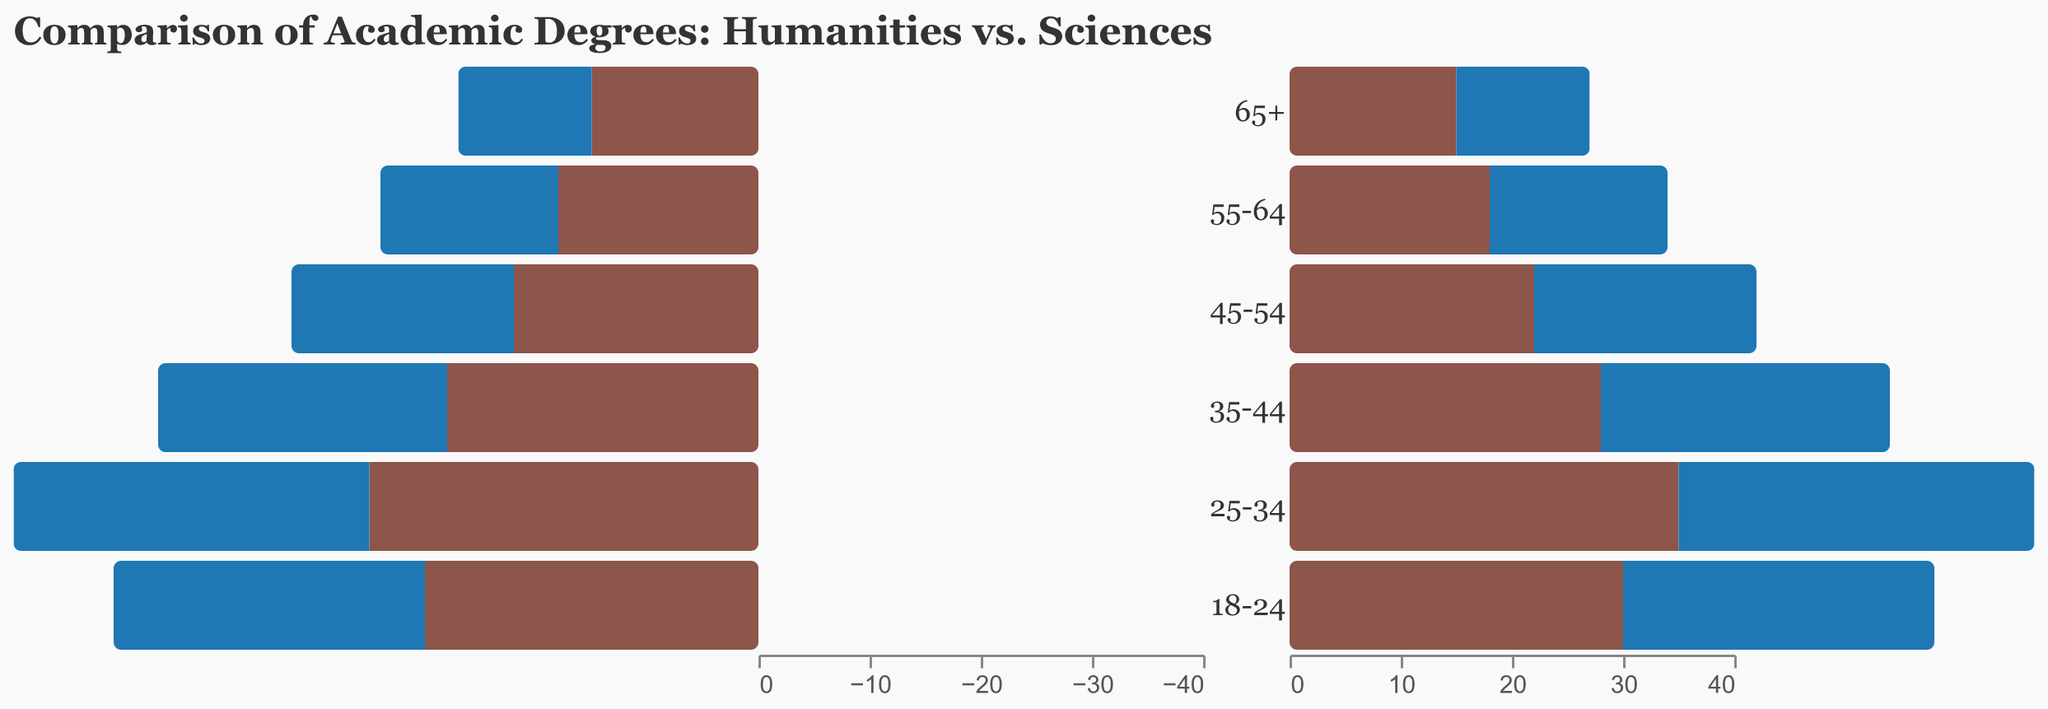What's the title of the figure? The title of the figure appears at the top and provides an indication of what the figure is about. In this case, it is "Comparison of Academic Degrees: Humanities vs. Sciences".
Answer: Comparison of Academic Degrees: Humanities vs. Sciences What color represents the Humanities degrees in the figure? Based on the legend and the color of the bars, Humanities degrees are represented by a specific color. Here, it's indicated by a shade of brown.
Answer: Brown Which age group shows the highest number of Science degrees? To find the age group with the highest number of Science degrees, observe the length of the blue bars representing Science degrees. The longest blue bar is for the age group "25-34".
Answer: 25-34 What is the difference in the number of Humanities degrees between the age groups 25-34 and 18-24? Find the values for these age groups in the Humanities column: -35 for 25-34 and -30 for 18-24. The difference is calculated as -35 - (-30) = -5.
Answer: -5 How do the trends in Humanities degrees compare to Science degrees across generations? Observe the trends in the lengths of both brown and blue bars from one age group to the next. Humanities degrees consistently decrease, while Science degrees consistently increase. This indicates a drop in Humanities degrees and a rise in Science degrees over time.
Answer: Humanities decrease, Sciences increase Which field has a larger discrepancy between the youngest (18-24) and oldest (65+) age groups? Calculate the difference for each field. For Humanities: -30 - (-15) = -15. For Sciences: 28 - 12 = 16. The larger discrepancy is in Science degrees.
Answer: Sciences In the age group 45-54, are there more academic degrees earned in Humanities or Sciences? Compare the length of the bars for Humanities and Sciences in the age group 45-54. Here, the bar for Science degrees (20) is longer than the bar for Humanities degrees (-22).
Answer: Sciences What is the total number of Science degrees earned by the age groups 18-24 and 25-34 combined? Add the number of Science degrees for these two age groups: 28 (18-24) + 32 (25-34) = 60.
Answer: 60 What does the relatively longer bar of Science degrees in the 35-44 age group indicate compared to the Humanities bar in the same group? The longer blue bar for Science degrees (26) compared to the brown bar for Humanities degrees (-28) indicates that more people in this age group earned Science degrees over Humanities degrees.
Answer: More Science degrees 